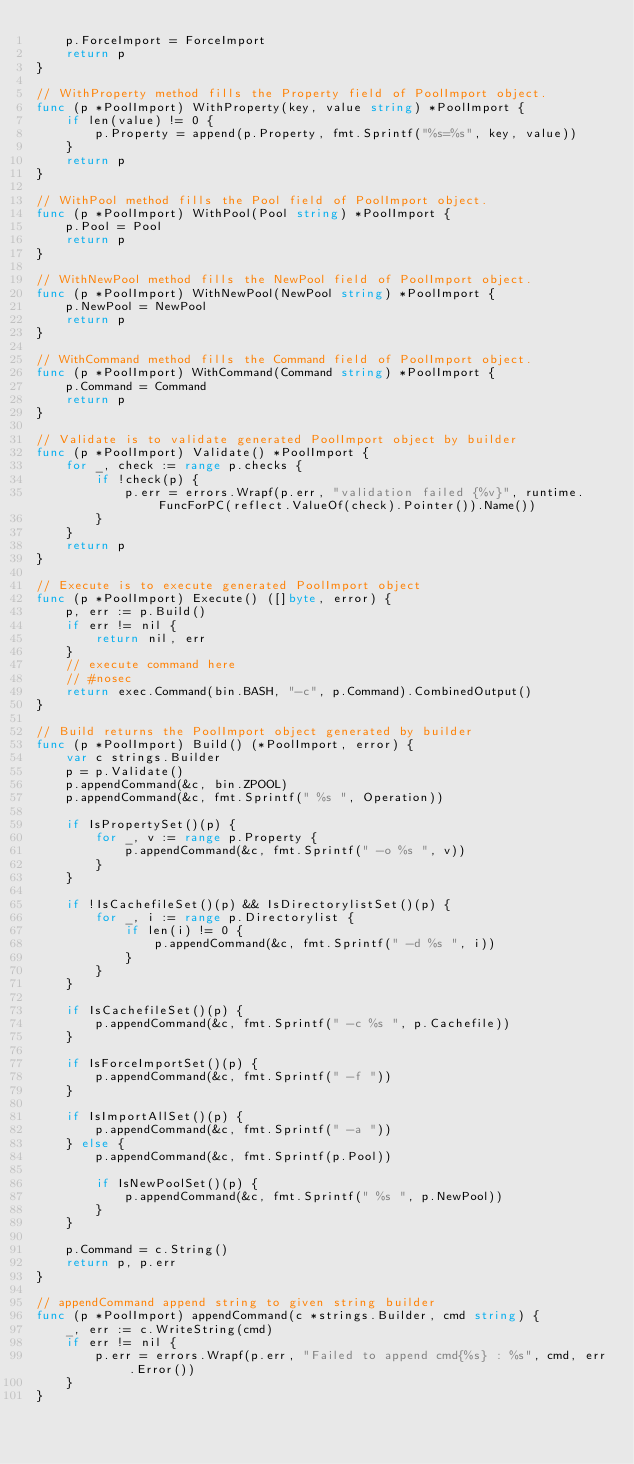<code> <loc_0><loc_0><loc_500><loc_500><_Go_>	p.ForceImport = ForceImport
	return p
}

// WithProperty method fills the Property field of PoolImport object.
func (p *PoolImport) WithProperty(key, value string) *PoolImport {
	if len(value) != 0 {
		p.Property = append(p.Property, fmt.Sprintf("%s=%s", key, value))
	}
	return p
}

// WithPool method fills the Pool field of PoolImport object.
func (p *PoolImport) WithPool(Pool string) *PoolImport {
	p.Pool = Pool
	return p
}

// WithNewPool method fills the NewPool field of PoolImport object.
func (p *PoolImport) WithNewPool(NewPool string) *PoolImport {
	p.NewPool = NewPool
	return p
}

// WithCommand method fills the Command field of PoolImport object.
func (p *PoolImport) WithCommand(Command string) *PoolImport {
	p.Command = Command
	return p
}

// Validate is to validate generated PoolImport object by builder
func (p *PoolImport) Validate() *PoolImport {
	for _, check := range p.checks {
		if !check(p) {
			p.err = errors.Wrapf(p.err, "validation failed {%v}", runtime.FuncForPC(reflect.ValueOf(check).Pointer()).Name())
		}
	}
	return p
}

// Execute is to execute generated PoolImport object
func (p *PoolImport) Execute() ([]byte, error) {
	p, err := p.Build()
	if err != nil {
		return nil, err
	}
	// execute command here
	// #nosec
	return exec.Command(bin.BASH, "-c", p.Command).CombinedOutput()
}

// Build returns the PoolImport object generated by builder
func (p *PoolImport) Build() (*PoolImport, error) {
	var c strings.Builder
	p = p.Validate()
	p.appendCommand(&c, bin.ZPOOL)
	p.appendCommand(&c, fmt.Sprintf(" %s ", Operation))

	if IsPropertySet()(p) {
		for _, v := range p.Property {
			p.appendCommand(&c, fmt.Sprintf(" -o %s ", v))
		}
	}

	if !IsCachefileSet()(p) && IsDirectorylistSet()(p) {
		for _, i := range p.Directorylist {
			if len(i) != 0 {
				p.appendCommand(&c, fmt.Sprintf(" -d %s ", i))
			}
		}
	}

	if IsCachefileSet()(p) {
		p.appendCommand(&c, fmt.Sprintf(" -c %s ", p.Cachefile))
	}

	if IsForceImportSet()(p) {
		p.appendCommand(&c, fmt.Sprintf(" -f "))
	}

	if IsImportAllSet()(p) {
		p.appendCommand(&c, fmt.Sprintf(" -a "))
	} else {
		p.appendCommand(&c, fmt.Sprintf(p.Pool))

		if IsNewPoolSet()(p) {
			p.appendCommand(&c, fmt.Sprintf(" %s ", p.NewPool))
		}
	}

	p.Command = c.String()
	return p, p.err
}

// appendCommand append string to given string builder
func (p *PoolImport) appendCommand(c *strings.Builder, cmd string) {
	_, err := c.WriteString(cmd)
	if err != nil {
		p.err = errors.Wrapf(p.err, "Failed to append cmd{%s} : %s", cmd, err.Error())
	}
}
</code> 